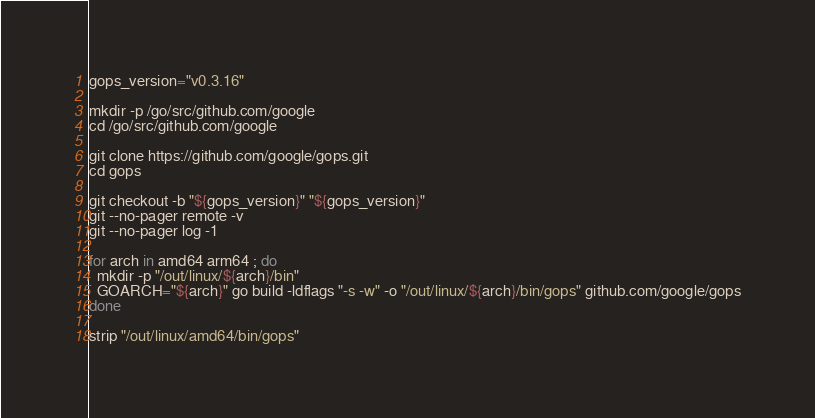<code> <loc_0><loc_0><loc_500><loc_500><_Bash_>gops_version="v0.3.16"

mkdir -p /go/src/github.com/google
cd /go/src/github.com/google

git clone https://github.com/google/gops.git
cd gops

git checkout -b "${gops_version}" "${gops_version}"
git --no-pager remote -v
git --no-pager log -1

for arch in amd64 arm64 ; do
  mkdir -p "/out/linux/${arch}/bin"
  GOARCH="${arch}" go build -ldflags "-s -w" -o "/out/linux/${arch}/bin/gops" github.com/google/gops
done

strip "/out/linux/amd64/bin/gops"</code> 